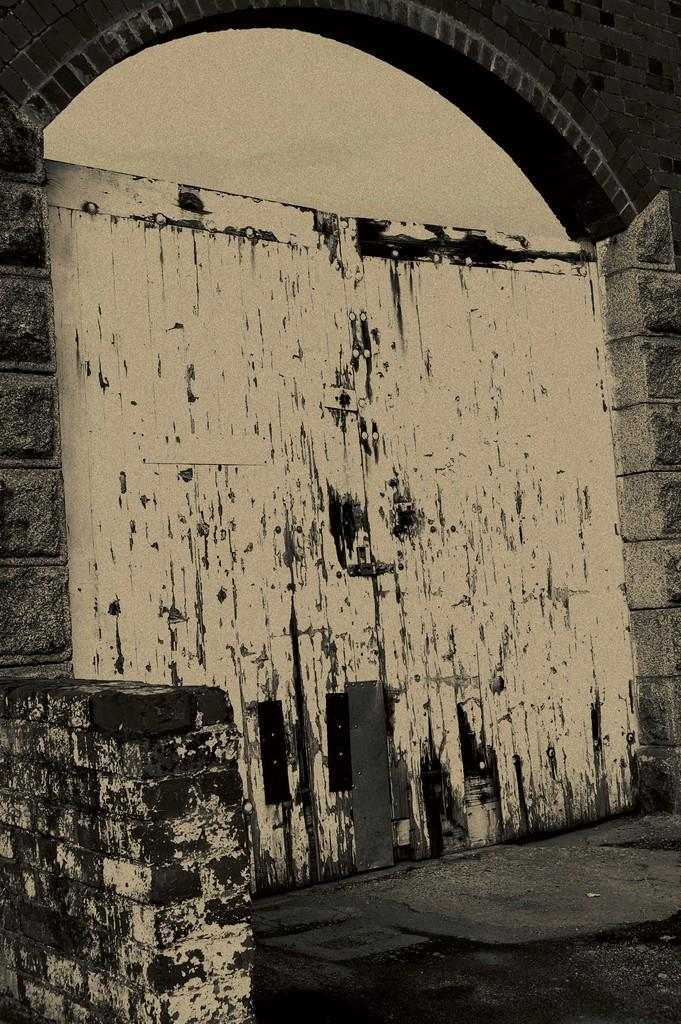What can be seen in the image? There is a wall in the image. Are there any openings or features on the wall? Yes, the wall has a door. What type of rhythm is being taught through the door in the image? There is no indication of any rhythm or teaching in the image; it simply shows a wall with a door. 